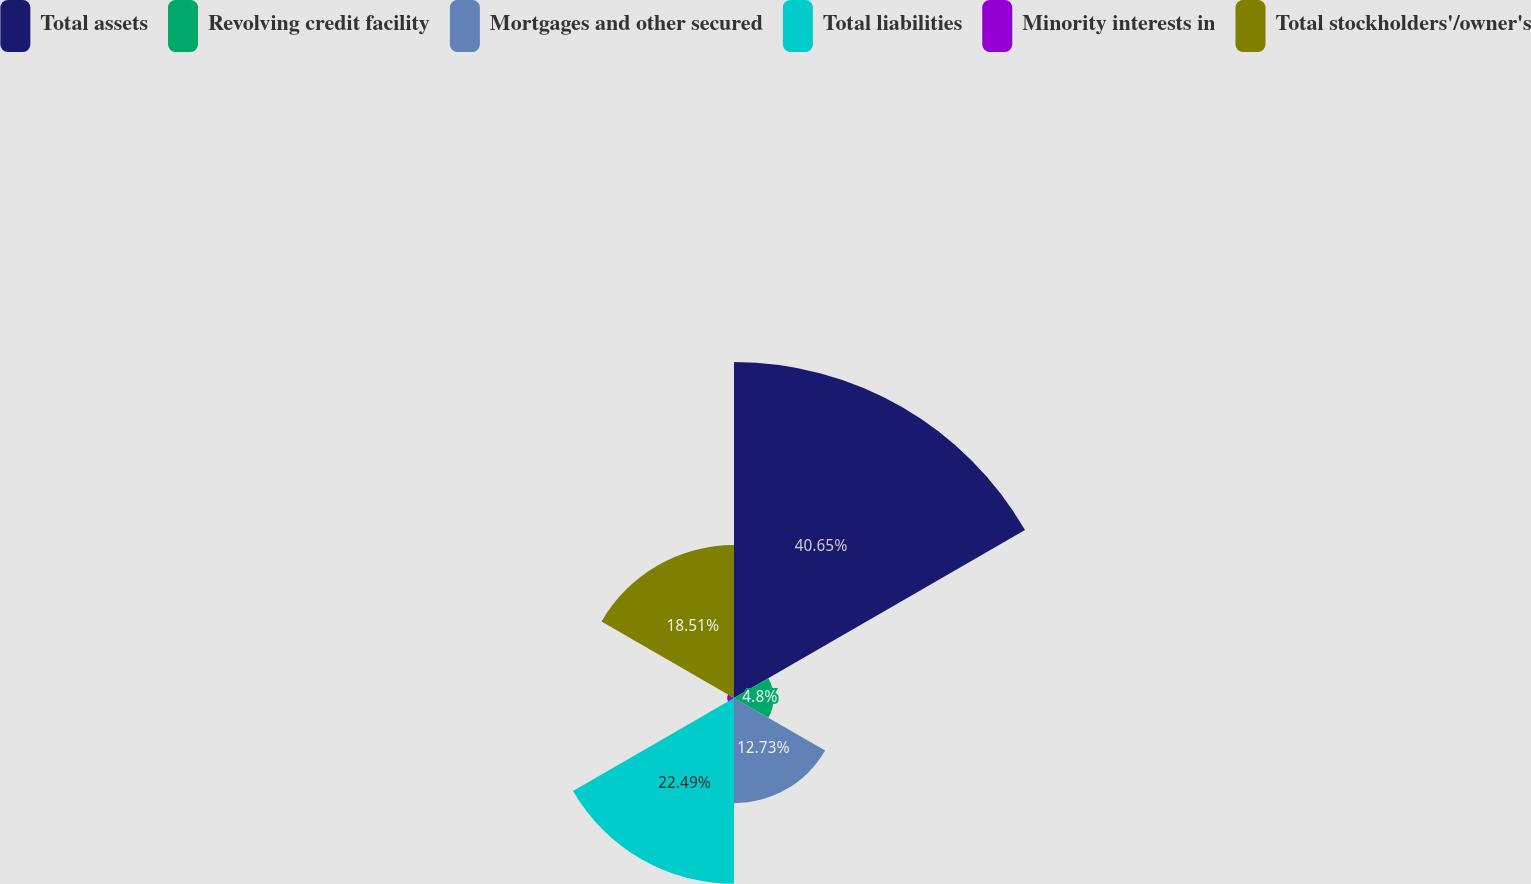<chart> <loc_0><loc_0><loc_500><loc_500><pie_chart><fcel>Total assets<fcel>Revolving credit facility<fcel>Mortgages and other secured<fcel>Total liabilities<fcel>Minority interests in<fcel>Total stockholders'/owner's<nl><fcel>40.66%<fcel>4.8%<fcel>12.73%<fcel>22.49%<fcel>0.82%<fcel>18.51%<nl></chart> 